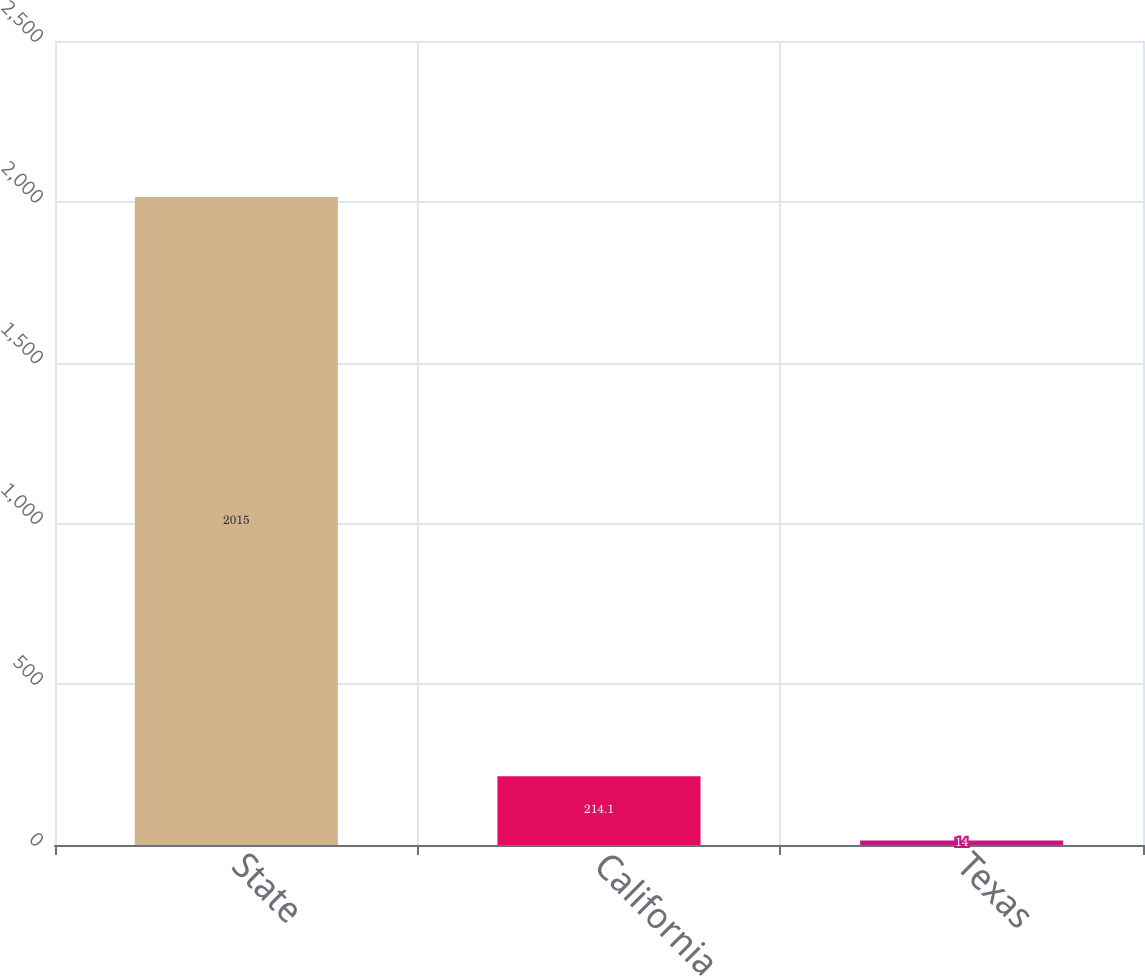<chart> <loc_0><loc_0><loc_500><loc_500><bar_chart><fcel>State<fcel>California<fcel>Texas<nl><fcel>2015<fcel>214.1<fcel>14<nl></chart> 